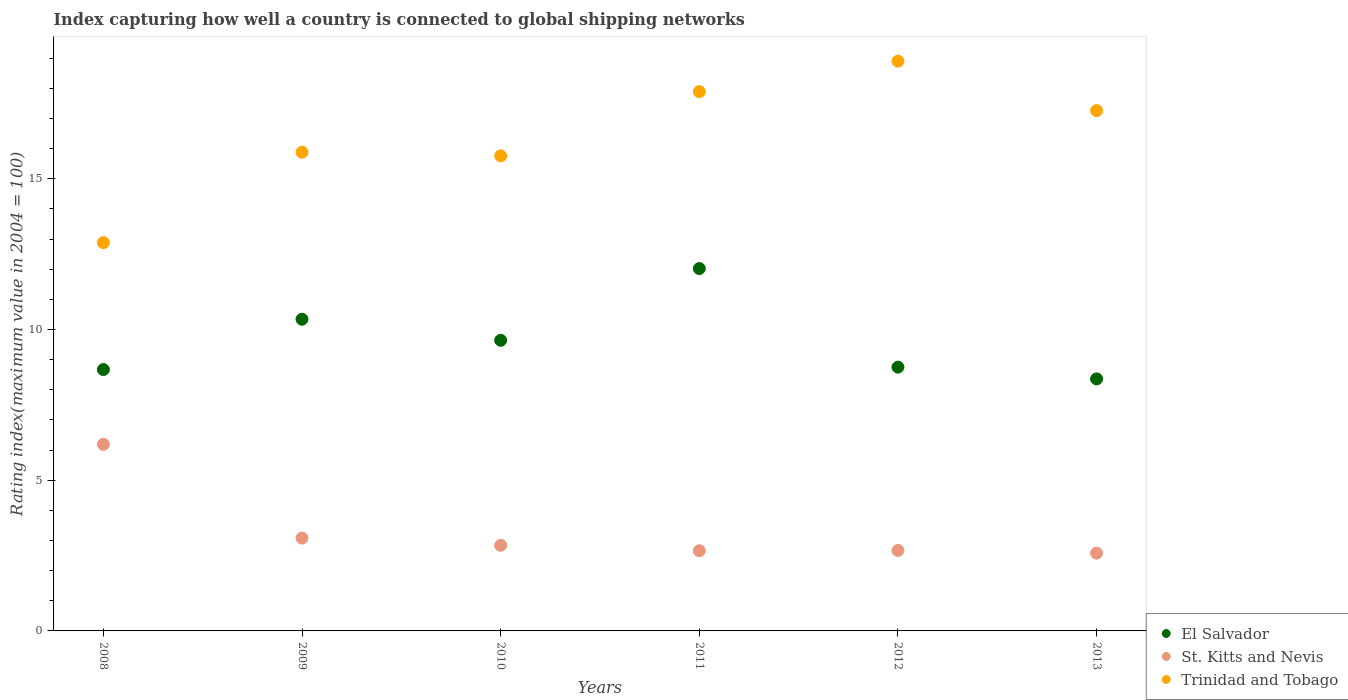How many different coloured dotlines are there?
Provide a succinct answer. 3. Is the number of dotlines equal to the number of legend labels?
Your answer should be very brief. Yes. What is the rating index in St. Kitts and Nevis in 2008?
Offer a very short reply. 6.19. Across all years, what is the maximum rating index in El Salvador?
Your response must be concise. 12.02. Across all years, what is the minimum rating index in St. Kitts and Nevis?
Give a very brief answer. 2.58. In which year was the rating index in El Salvador maximum?
Give a very brief answer. 2011. In which year was the rating index in El Salvador minimum?
Make the answer very short. 2013. What is the total rating index in St. Kitts and Nevis in the graph?
Keep it short and to the point. 20.02. What is the difference between the rating index in St. Kitts and Nevis in 2010 and that in 2012?
Your answer should be compact. 0.17. What is the difference between the rating index in St. Kitts and Nevis in 2010 and the rating index in Trinidad and Tobago in 2009?
Keep it short and to the point. -13.04. What is the average rating index in St. Kitts and Nevis per year?
Make the answer very short. 3.34. In the year 2011, what is the difference between the rating index in El Salvador and rating index in St. Kitts and Nevis?
Give a very brief answer. 9.36. In how many years, is the rating index in St. Kitts and Nevis greater than 2?
Offer a very short reply. 6. What is the ratio of the rating index in El Salvador in 2008 to that in 2013?
Offer a very short reply. 1.04. What is the difference between the highest and the second highest rating index in Trinidad and Tobago?
Offer a terse response. 1.01. What is the difference between the highest and the lowest rating index in El Salvador?
Provide a short and direct response. 3.66. In how many years, is the rating index in El Salvador greater than the average rating index in El Salvador taken over all years?
Ensure brevity in your answer.  3. Is the sum of the rating index in St. Kitts and Nevis in 2008 and 2011 greater than the maximum rating index in Trinidad and Tobago across all years?
Your answer should be compact. No. Does the rating index in El Salvador monotonically increase over the years?
Provide a short and direct response. No. Is the rating index in St. Kitts and Nevis strictly greater than the rating index in El Salvador over the years?
Your response must be concise. No. Is the rating index in Trinidad and Tobago strictly less than the rating index in El Salvador over the years?
Keep it short and to the point. No. How many years are there in the graph?
Make the answer very short. 6. Are the values on the major ticks of Y-axis written in scientific E-notation?
Your response must be concise. No. Where does the legend appear in the graph?
Your answer should be compact. Bottom right. How are the legend labels stacked?
Keep it short and to the point. Vertical. What is the title of the graph?
Your answer should be very brief. Index capturing how well a country is connected to global shipping networks. What is the label or title of the X-axis?
Provide a succinct answer. Years. What is the label or title of the Y-axis?
Your response must be concise. Rating index(maximum value in 2004 = 100). What is the Rating index(maximum value in 2004 = 100) of El Salvador in 2008?
Keep it short and to the point. 8.67. What is the Rating index(maximum value in 2004 = 100) in St. Kitts and Nevis in 2008?
Provide a succinct answer. 6.19. What is the Rating index(maximum value in 2004 = 100) of Trinidad and Tobago in 2008?
Your answer should be very brief. 12.88. What is the Rating index(maximum value in 2004 = 100) of El Salvador in 2009?
Your answer should be very brief. 10.34. What is the Rating index(maximum value in 2004 = 100) in St. Kitts and Nevis in 2009?
Your response must be concise. 3.08. What is the Rating index(maximum value in 2004 = 100) of Trinidad and Tobago in 2009?
Your answer should be very brief. 15.88. What is the Rating index(maximum value in 2004 = 100) in El Salvador in 2010?
Keep it short and to the point. 9.64. What is the Rating index(maximum value in 2004 = 100) in St. Kitts and Nevis in 2010?
Ensure brevity in your answer.  2.84. What is the Rating index(maximum value in 2004 = 100) in Trinidad and Tobago in 2010?
Make the answer very short. 15.76. What is the Rating index(maximum value in 2004 = 100) of El Salvador in 2011?
Provide a succinct answer. 12.02. What is the Rating index(maximum value in 2004 = 100) in St. Kitts and Nevis in 2011?
Provide a short and direct response. 2.66. What is the Rating index(maximum value in 2004 = 100) in Trinidad and Tobago in 2011?
Make the answer very short. 17.89. What is the Rating index(maximum value in 2004 = 100) of El Salvador in 2012?
Provide a short and direct response. 8.75. What is the Rating index(maximum value in 2004 = 100) of St. Kitts and Nevis in 2012?
Offer a terse response. 2.67. What is the Rating index(maximum value in 2004 = 100) in Trinidad and Tobago in 2012?
Offer a terse response. 18.9. What is the Rating index(maximum value in 2004 = 100) of El Salvador in 2013?
Give a very brief answer. 8.36. What is the Rating index(maximum value in 2004 = 100) in St. Kitts and Nevis in 2013?
Provide a succinct answer. 2.58. What is the Rating index(maximum value in 2004 = 100) in Trinidad and Tobago in 2013?
Your response must be concise. 17.26. Across all years, what is the maximum Rating index(maximum value in 2004 = 100) in El Salvador?
Give a very brief answer. 12.02. Across all years, what is the maximum Rating index(maximum value in 2004 = 100) in St. Kitts and Nevis?
Provide a short and direct response. 6.19. Across all years, what is the minimum Rating index(maximum value in 2004 = 100) in El Salvador?
Offer a terse response. 8.36. Across all years, what is the minimum Rating index(maximum value in 2004 = 100) in St. Kitts and Nevis?
Make the answer very short. 2.58. Across all years, what is the minimum Rating index(maximum value in 2004 = 100) in Trinidad and Tobago?
Your answer should be very brief. 12.88. What is the total Rating index(maximum value in 2004 = 100) of El Salvador in the graph?
Provide a succinct answer. 57.78. What is the total Rating index(maximum value in 2004 = 100) in St. Kitts and Nevis in the graph?
Make the answer very short. 20.02. What is the total Rating index(maximum value in 2004 = 100) in Trinidad and Tobago in the graph?
Make the answer very short. 98.57. What is the difference between the Rating index(maximum value in 2004 = 100) in El Salvador in 2008 and that in 2009?
Make the answer very short. -1.67. What is the difference between the Rating index(maximum value in 2004 = 100) in St. Kitts and Nevis in 2008 and that in 2009?
Ensure brevity in your answer.  3.11. What is the difference between the Rating index(maximum value in 2004 = 100) in El Salvador in 2008 and that in 2010?
Ensure brevity in your answer.  -0.97. What is the difference between the Rating index(maximum value in 2004 = 100) in St. Kitts and Nevis in 2008 and that in 2010?
Make the answer very short. 3.35. What is the difference between the Rating index(maximum value in 2004 = 100) of Trinidad and Tobago in 2008 and that in 2010?
Your answer should be compact. -2.88. What is the difference between the Rating index(maximum value in 2004 = 100) in El Salvador in 2008 and that in 2011?
Offer a very short reply. -3.35. What is the difference between the Rating index(maximum value in 2004 = 100) of St. Kitts and Nevis in 2008 and that in 2011?
Keep it short and to the point. 3.53. What is the difference between the Rating index(maximum value in 2004 = 100) of Trinidad and Tobago in 2008 and that in 2011?
Give a very brief answer. -5.01. What is the difference between the Rating index(maximum value in 2004 = 100) of El Salvador in 2008 and that in 2012?
Provide a succinct answer. -0.08. What is the difference between the Rating index(maximum value in 2004 = 100) of St. Kitts and Nevis in 2008 and that in 2012?
Your answer should be very brief. 3.52. What is the difference between the Rating index(maximum value in 2004 = 100) of Trinidad and Tobago in 2008 and that in 2012?
Your answer should be very brief. -6.02. What is the difference between the Rating index(maximum value in 2004 = 100) in El Salvador in 2008 and that in 2013?
Your answer should be very brief. 0.31. What is the difference between the Rating index(maximum value in 2004 = 100) in St. Kitts and Nevis in 2008 and that in 2013?
Keep it short and to the point. 3.61. What is the difference between the Rating index(maximum value in 2004 = 100) in Trinidad and Tobago in 2008 and that in 2013?
Your answer should be very brief. -4.38. What is the difference between the Rating index(maximum value in 2004 = 100) of El Salvador in 2009 and that in 2010?
Your response must be concise. 0.7. What is the difference between the Rating index(maximum value in 2004 = 100) in St. Kitts and Nevis in 2009 and that in 2010?
Offer a terse response. 0.24. What is the difference between the Rating index(maximum value in 2004 = 100) of Trinidad and Tobago in 2009 and that in 2010?
Keep it short and to the point. 0.12. What is the difference between the Rating index(maximum value in 2004 = 100) in El Salvador in 2009 and that in 2011?
Make the answer very short. -1.68. What is the difference between the Rating index(maximum value in 2004 = 100) of St. Kitts and Nevis in 2009 and that in 2011?
Provide a succinct answer. 0.42. What is the difference between the Rating index(maximum value in 2004 = 100) in Trinidad and Tobago in 2009 and that in 2011?
Ensure brevity in your answer.  -2.01. What is the difference between the Rating index(maximum value in 2004 = 100) in El Salvador in 2009 and that in 2012?
Provide a succinct answer. 1.59. What is the difference between the Rating index(maximum value in 2004 = 100) of St. Kitts and Nevis in 2009 and that in 2012?
Make the answer very short. 0.41. What is the difference between the Rating index(maximum value in 2004 = 100) in Trinidad and Tobago in 2009 and that in 2012?
Offer a very short reply. -3.02. What is the difference between the Rating index(maximum value in 2004 = 100) in El Salvador in 2009 and that in 2013?
Make the answer very short. 1.98. What is the difference between the Rating index(maximum value in 2004 = 100) in St. Kitts and Nevis in 2009 and that in 2013?
Keep it short and to the point. 0.5. What is the difference between the Rating index(maximum value in 2004 = 100) in Trinidad and Tobago in 2009 and that in 2013?
Give a very brief answer. -1.38. What is the difference between the Rating index(maximum value in 2004 = 100) in El Salvador in 2010 and that in 2011?
Offer a terse response. -2.38. What is the difference between the Rating index(maximum value in 2004 = 100) of St. Kitts and Nevis in 2010 and that in 2011?
Ensure brevity in your answer.  0.18. What is the difference between the Rating index(maximum value in 2004 = 100) of Trinidad and Tobago in 2010 and that in 2011?
Provide a succinct answer. -2.13. What is the difference between the Rating index(maximum value in 2004 = 100) in El Salvador in 2010 and that in 2012?
Give a very brief answer. 0.89. What is the difference between the Rating index(maximum value in 2004 = 100) in St. Kitts and Nevis in 2010 and that in 2012?
Give a very brief answer. 0.17. What is the difference between the Rating index(maximum value in 2004 = 100) of Trinidad and Tobago in 2010 and that in 2012?
Provide a short and direct response. -3.14. What is the difference between the Rating index(maximum value in 2004 = 100) in El Salvador in 2010 and that in 2013?
Offer a terse response. 1.28. What is the difference between the Rating index(maximum value in 2004 = 100) in St. Kitts and Nevis in 2010 and that in 2013?
Offer a very short reply. 0.26. What is the difference between the Rating index(maximum value in 2004 = 100) of El Salvador in 2011 and that in 2012?
Your answer should be very brief. 3.27. What is the difference between the Rating index(maximum value in 2004 = 100) in St. Kitts and Nevis in 2011 and that in 2012?
Give a very brief answer. -0.01. What is the difference between the Rating index(maximum value in 2004 = 100) of Trinidad and Tobago in 2011 and that in 2012?
Offer a terse response. -1.01. What is the difference between the Rating index(maximum value in 2004 = 100) of El Salvador in 2011 and that in 2013?
Give a very brief answer. 3.66. What is the difference between the Rating index(maximum value in 2004 = 100) of St. Kitts and Nevis in 2011 and that in 2013?
Provide a succinct answer. 0.08. What is the difference between the Rating index(maximum value in 2004 = 100) of Trinidad and Tobago in 2011 and that in 2013?
Provide a short and direct response. 0.63. What is the difference between the Rating index(maximum value in 2004 = 100) of El Salvador in 2012 and that in 2013?
Provide a short and direct response. 0.39. What is the difference between the Rating index(maximum value in 2004 = 100) in St. Kitts and Nevis in 2012 and that in 2013?
Offer a very short reply. 0.09. What is the difference between the Rating index(maximum value in 2004 = 100) in Trinidad and Tobago in 2012 and that in 2013?
Offer a terse response. 1.64. What is the difference between the Rating index(maximum value in 2004 = 100) in El Salvador in 2008 and the Rating index(maximum value in 2004 = 100) in St. Kitts and Nevis in 2009?
Provide a short and direct response. 5.59. What is the difference between the Rating index(maximum value in 2004 = 100) in El Salvador in 2008 and the Rating index(maximum value in 2004 = 100) in Trinidad and Tobago in 2009?
Ensure brevity in your answer.  -7.21. What is the difference between the Rating index(maximum value in 2004 = 100) of St. Kitts and Nevis in 2008 and the Rating index(maximum value in 2004 = 100) of Trinidad and Tobago in 2009?
Ensure brevity in your answer.  -9.69. What is the difference between the Rating index(maximum value in 2004 = 100) of El Salvador in 2008 and the Rating index(maximum value in 2004 = 100) of St. Kitts and Nevis in 2010?
Provide a short and direct response. 5.83. What is the difference between the Rating index(maximum value in 2004 = 100) in El Salvador in 2008 and the Rating index(maximum value in 2004 = 100) in Trinidad and Tobago in 2010?
Offer a terse response. -7.09. What is the difference between the Rating index(maximum value in 2004 = 100) in St. Kitts and Nevis in 2008 and the Rating index(maximum value in 2004 = 100) in Trinidad and Tobago in 2010?
Your response must be concise. -9.57. What is the difference between the Rating index(maximum value in 2004 = 100) in El Salvador in 2008 and the Rating index(maximum value in 2004 = 100) in St. Kitts and Nevis in 2011?
Keep it short and to the point. 6.01. What is the difference between the Rating index(maximum value in 2004 = 100) of El Salvador in 2008 and the Rating index(maximum value in 2004 = 100) of Trinidad and Tobago in 2011?
Your answer should be very brief. -9.22. What is the difference between the Rating index(maximum value in 2004 = 100) of St. Kitts and Nevis in 2008 and the Rating index(maximum value in 2004 = 100) of Trinidad and Tobago in 2011?
Ensure brevity in your answer.  -11.7. What is the difference between the Rating index(maximum value in 2004 = 100) in El Salvador in 2008 and the Rating index(maximum value in 2004 = 100) in St. Kitts and Nevis in 2012?
Ensure brevity in your answer.  6. What is the difference between the Rating index(maximum value in 2004 = 100) of El Salvador in 2008 and the Rating index(maximum value in 2004 = 100) of Trinidad and Tobago in 2012?
Make the answer very short. -10.23. What is the difference between the Rating index(maximum value in 2004 = 100) in St. Kitts and Nevis in 2008 and the Rating index(maximum value in 2004 = 100) in Trinidad and Tobago in 2012?
Your response must be concise. -12.71. What is the difference between the Rating index(maximum value in 2004 = 100) of El Salvador in 2008 and the Rating index(maximum value in 2004 = 100) of St. Kitts and Nevis in 2013?
Ensure brevity in your answer.  6.09. What is the difference between the Rating index(maximum value in 2004 = 100) in El Salvador in 2008 and the Rating index(maximum value in 2004 = 100) in Trinidad and Tobago in 2013?
Give a very brief answer. -8.59. What is the difference between the Rating index(maximum value in 2004 = 100) of St. Kitts and Nevis in 2008 and the Rating index(maximum value in 2004 = 100) of Trinidad and Tobago in 2013?
Your answer should be very brief. -11.07. What is the difference between the Rating index(maximum value in 2004 = 100) in El Salvador in 2009 and the Rating index(maximum value in 2004 = 100) in Trinidad and Tobago in 2010?
Your answer should be very brief. -5.42. What is the difference between the Rating index(maximum value in 2004 = 100) in St. Kitts and Nevis in 2009 and the Rating index(maximum value in 2004 = 100) in Trinidad and Tobago in 2010?
Offer a very short reply. -12.68. What is the difference between the Rating index(maximum value in 2004 = 100) in El Salvador in 2009 and the Rating index(maximum value in 2004 = 100) in St. Kitts and Nevis in 2011?
Ensure brevity in your answer.  7.68. What is the difference between the Rating index(maximum value in 2004 = 100) in El Salvador in 2009 and the Rating index(maximum value in 2004 = 100) in Trinidad and Tobago in 2011?
Make the answer very short. -7.55. What is the difference between the Rating index(maximum value in 2004 = 100) in St. Kitts and Nevis in 2009 and the Rating index(maximum value in 2004 = 100) in Trinidad and Tobago in 2011?
Your answer should be compact. -14.81. What is the difference between the Rating index(maximum value in 2004 = 100) in El Salvador in 2009 and the Rating index(maximum value in 2004 = 100) in St. Kitts and Nevis in 2012?
Offer a terse response. 7.67. What is the difference between the Rating index(maximum value in 2004 = 100) of El Salvador in 2009 and the Rating index(maximum value in 2004 = 100) of Trinidad and Tobago in 2012?
Provide a succinct answer. -8.56. What is the difference between the Rating index(maximum value in 2004 = 100) of St. Kitts and Nevis in 2009 and the Rating index(maximum value in 2004 = 100) of Trinidad and Tobago in 2012?
Your response must be concise. -15.82. What is the difference between the Rating index(maximum value in 2004 = 100) of El Salvador in 2009 and the Rating index(maximum value in 2004 = 100) of St. Kitts and Nevis in 2013?
Your response must be concise. 7.76. What is the difference between the Rating index(maximum value in 2004 = 100) of El Salvador in 2009 and the Rating index(maximum value in 2004 = 100) of Trinidad and Tobago in 2013?
Your answer should be very brief. -6.92. What is the difference between the Rating index(maximum value in 2004 = 100) of St. Kitts and Nevis in 2009 and the Rating index(maximum value in 2004 = 100) of Trinidad and Tobago in 2013?
Make the answer very short. -14.18. What is the difference between the Rating index(maximum value in 2004 = 100) in El Salvador in 2010 and the Rating index(maximum value in 2004 = 100) in St. Kitts and Nevis in 2011?
Ensure brevity in your answer.  6.98. What is the difference between the Rating index(maximum value in 2004 = 100) of El Salvador in 2010 and the Rating index(maximum value in 2004 = 100) of Trinidad and Tobago in 2011?
Offer a very short reply. -8.25. What is the difference between the Rating index(maximum value in 2004 = 100) in St. Kitts and Nevis in 2010 and the Rating index(maximum value in 2004 = 100) in Trinidad and Tobago in 2011?
Your answer should be compact. -15.05. What is the difference between the Rating index(maximum value in 2004 = 100) in El Salvador in 2010 and the Rating index(maximum value in 2004 = 100) in St. Kitts and Nevis in 2012?
Make the answer very short. 6.97. What is the difference between the Rating index(maximum value in 2004 = 100) of El Salvador in 2010 and the Rating index(maximum value in 2004 = 100) of Trinidad and Tobago in 2012?
Offer a very short reply. -9.26. What is the difference between the Rating index(maximum value in 2004 = 100) in St. Kitts and Nevis in 2010 and the Rating index(maximum value in 2004 = 100) in Trinidad and Tobago in 2012?
Offer a terse response. -16.06. What is the difference between the Rating index(maximum value in 2004 = 100) in El Salvador in 2010 and the Rating index(maximum value in 2004 = 100) in St. Kitts and Nevis in 2013?
Offer a terse response. 7.06. What is the difference between the Rating index(maximum value in 2004 = 100) of El Salvador in 2010 and the Rating index(maximum value in 2004 = 100) of Trinidad and Tobago in 2013?
Offer a terse response. -7.62. What is the difference between the Rating index(maximum value in 2004 = 100) of St. Kitts and Nevis in 2010 and the Rating index(maximum value in 2004 = 100) of Trinidad and Tobago in 2013?
Keep it short and to the point. -14.42. What is the difference between the Rating index(maximum value in 2004 = 100) in El Salvador in 2011 and the Rating index(maximum value in 2004 = 100) in St. Kitts and Nevis in 2012?
Your answer should be compact. 9.35. What is the difference between the Rating index(maximum value in 2004 = 100) in El Salvador in 2011 and the Rating index(maximum value in 2004 = 100) in Trinidad and Tobago in 2012?
Keep it short and to the point. -6.88. What is the difference between the Rating index(maximum value in 2004 = 100) in St. Kitts and Nevis in 2011 and the Rating index(maximum value in 2004 = 100) in Trinidad and Tobago in 2012?
Your answer should be compact. -16.24. What is the difference between the Rating index(maximum value in 2004 = 100) of El Salvador in 2011 and the Rating index(maximum value in 2004 = 100) of St. Kitts and Nevis in 2013?
Provide a short and direct response. 9.44. What is the difference between the Rating index(maximum value in 2004 = 100) of El Salvador in 2011 and the Rating index(maximum value in 2004 = 100) of Trinidad and Tobago in 2013?
Offer a very short reply. -5.24. What is the difference between the Rating index(maximum value in 2004 = 100) of St. Kitts and Nevis in 2011 and the Rating index(maximum value in 2004 = 100) of Trinidad and Tobago in 2013?
Your answer should be compact. -14.6. What is the difference between the Rating index(maximum value in 2004 = 100) of El Salvador in 2012 and the Rating index(maximum value in 2004 = 100) of St. Kitts and Nevis in 2013?
Provide a short and direct response. 6.17. What is the difference between the Rating index(maximum value in 2004 = 100) in El Salvador in 2012 and the Rating index(maximum value in 2004 = 100) in Trinidad and Tobago in 2013?
Ensure brevity in your answer.  -8.51. What is the difference between the Rating index(maximum value in 2004 = 100) in St. Kitts and Nevis in 2012 and the Rating index(maximum value in 2004 = 100) in Trinidad and Tobago in 2013?
Ensure brevity in your answer.  -14.59. What is the average Rating index(maximum value in 2004 = 100) of El Salvador per year?
Provide a succinct answer. 9.63. What is the average Rating index(maximum value in 2004 = 100) in St. Kitts and Nevis per year?
Give a very brief answer. 3.34. What is the average Rating index(maximum value in 2004 = 100) of Trinidad and Tobago per year?
Your response must be concise. 16.43. In the year 2008, what is the difference between the Rating index(maximum value in 2004 = 100) of El Salvador and Rating index(maximum value in 2004 = 100) of St. Kitts and Nevis?
Offer a terse response. 2.48. In the year 2008, what is the difference between the Rating index(maximum value in 2004 = 100) of El Salvador and Rating index(maximum value in 2004 = 100) of Trinidad and Tobago?
Provide a short and direct response. -4.21. In the year 2008, what is the difference between the Rating index(maximum value in 2004 = 100) in St. Kitts and Nevis and Rating index(maximum value in 2004 = 100) in Trinidad and Tobago?
Make the answer very short. -6.69. In the year 2009, what is the difference between the Rating index(maximum value in 2004 = 100) in El Salvador and Rating index(maximum value in 2004 = 100) in St. Kitts and Nevis?
Give a very brief answer. 7.26. In the year 2009, what is the difference between the Rating index(maximum value in 2004 = 100) of El Salvador and Rating index(maximum value in 2004 = 100) of Trinidad and Tobago?
Your answer should be very brief. -5.54. In the year 2009, what is the difference between the Rating index(maximum value in 2004 = 100) of St. Kitts and Nevis and Rating index(maximum value in 2004 = 100) of Trinidad and Tobago?
Give a very brief answer. -12.8. In the year 2010, what is the difference between the Rating index(maximum value in 2004 = 100) in El Salvador and Rating index(maximum value in 2004 = 100) in St. Kitts and Nevis?
Ensure brevity in your answer.  6.8. In the year 2010, what is the difference between the Rating index(maximum value in 2004 = 100) of El Salvador and Rating index(maximum value in 2004 = 100) of Trinidad and Tobago?
Your answer should be compact. -6.12. In the year 2010, what is the difference between the Rating index(maximum value in 2004 = 100) of St. Kitts and Nevis and Rating index(maximum value in 2004 = 100) of Trinidad and Tobago?
Keep it short and to the point. -12.92. In the year 2011, what is the difference between the Rating index(maximum value in 2004 = 100) in El Salvador and Rating index(maximum value in 2004 = 100) in St. Kitts and Nevis?
Give a very brief answer. 9.36. In the year 2011, what is the difference between the Rating index(maximum value in 2004 = 100) in El Salvador and Rating index(maximum value in 2004 = 100) in Trinidad and Tobago?
Keep it short and to the point. -5.87. In the year 2011, what is the difference between the Rating index(maximum value in 2004 = 100) in St. Kitts and Nevis and Rating index(maximum value in 2004 = 100) in Trinidad and Tobago?
Provide a short and direct response. -15.23. In the year 2012, what is the difference between the Rating index(maximum value in 2004 = 100) of El Salvador and Rating index(maximum value in 2004 = 100) of St. Kitts and Nevis?
Ensure brevity in your answer.  6.08. In the year 2012, what is the difference between the Rating index(maximum value in 2004 = 100) of El Salvador and Rating index(maximum value in 2004 = 100) of Trinidad and Tobago?
Offer a terse response. -10.15. In the year 2012, what is the difference between the Rating index(maximum value in 2004 = 100) of St. Kitts and Nevis and Rating index(maximum value in 2004 = 100) of Trinidad and Tobago?
Your answer should be compact. -16.23. In the year 2013, what is the difference between the Rating index(maximum value in 2004 = 100) in El Salvador and Rating index(maximum value in 2004 = 100) in St. Kitts and Nevis?
Give a very brief answer. 5.78. In the year 2013, what is the difference between the Rating index(maximum value in 2004 = 100) of St. Kitts and Nevis and Rating index(maximum value in 2004 = 100) of Trinidad and Tobago?
Offer a terse response. -14.68. What is the ratio of the Rating index(maximum value in 2004 = 100) of El Salvador in 2008 to that in 2009?
Provide a short and direct response. 0.84. What is the ratio of the Rating index(maximum value in 2004 = 100) in St. Kitts and Nevis in 2008 to that in 2009?
Provide a short and direct response. 2.01. What is the ratio of the Rating index(maximum value in 2004 = 100) in Trinidad and Tobago in 2008 to that in 2009?
Offer a terse response. 0.81. What is the ratio of the Rating index(maximum value in 2004 = 100) in El Salvador in 2008 to that in 2010?
Give a very brief answer. 0.9. What is the ratio of the Rating index(maximum value in 2004 = 100) of St. Kitts and Nevis in 2008 to that in 2010?
Provide a short and direct response. 2.18. What is the ratio of the Rating index(maximum value in 2004 = 100) of Trinidad and Tobago in 2008 to that in 2010?
Provide a succinct answer. 0.82. What is the ratio of the Rating index(maximum value in 2004 = 100) of El Salvador in 2008 to that in 2011?
Your response must be concise. 0.72. What is the ratio of the Rating index(maximum value in 2004 = 100) in St. Kitts and Nevis in 2008 to that in 2011?
Your response must be concise. 2.33. What is the ratio of the Rating index(maximum value in 2004 = 100) of Trinidad and Tobago in 2008 to that in 2011?
Your response must be concise. 0.72. What is the ratio of the Rating index(maximum value in 2004 = 100) of El Salvador in 2008 to that in 2012?
Give a very brief answer. 0.99. What is the ratio of the Rating index(maximum value in 2004 = 100) of St. Kitts and Nevis in 2008 to that in 2012?
Keep it short and to the point. 2.32. What is the ratio of the Rating index(maximum value in 2004 = 100) in Trinidad and Tobago in 2008 to that in 2012?
Provide a succinct answer. 0.68. What is the ratio of the Rating index(maximum value in 2004 = 100) in El Salvador in 2008 to that in 2013?
Ensure brevity in your answer.  1.04. What is the ratio of the Rating index(maximum value in 2004 = 100) of St. Kitts and Nevis in 2008 to that in 2013?
Your answer should be very brief. 2.4. What is the ratio of the Rating index(maximum value in 2004 = 100) in Trinidad and Tobago in 2008 to that in 2013?
Ensure brevity in your answer.  0.75. What is the ratio of the Rating index(maximum value in 2004 = 100) of El Salvador in 2009 to that in 2010?
Your answer should be very brief. 1.07. What is the ratio of the Rating index(maximum value in 2004 = 100) in St. Kitts and Nevis in 2009 to that in 2010?
Provide a succinct answer. 1.08. What is the ratio of the Rating index(maximum value in 2004 = 100) of Trinidad and Tobago in 2009 to that in 2010?
Provide a short and direct response. 1.01. What is the ratio of the Rating index(maximum value in 2004 = 100) of El Salvador in 2009 to that in 2011?
Make the answer very short. 0.86. What is the ratio of the Rating index(maximum value in 2004 = 100) in St. Kitts and Nevis in 2009 to that in 2011?
Provide a succinct answer. 1.16. What is the ratio of the Rating index(maximum value in 2004 = 100) of Trinidad and Tobago in 2009 to that in 2011?
Provide a succinct answer. 0.89. What is the ratio of the Rating index(maximum value in 2004 = 100) of El Salvador in 2009 to that in 2012?
Give a very brief answer. 1.18. What is the ratio of the Rating index(maximum value in 2004 = 100) in St. Kitts and Nevis in 2009 to that in 2012?
Make the answer very short. 1.15. What is the ratio of the Rating index(maximum value in 2004 = 100) of Trinidad and Tobago in 2009 to that in 2012?
Make the answer very short. 0.84. What is the ratio of the Rating index(maximum value in 2004 = 100) in El Salvador in 2009 to that in 2013?
Your answer should be compact. 1.24. What is the ratio of the Rating index(maximum value in 2004 = 100) of St. Kitts and Nevis in 2009 to that in 2013?
Your response must be concise. 1.19. What is the ratio of the Rating index(maximum value in 2004 = 100) of Trinidad and Tobago in 2009 to that in 2013?
Your answer should be compact. 0.92. What is the ratio of the Rating index(maximum value in 2004 = 100) of El Salvador in 2010 to that in 2011?
Keep it short and to the point. 0.8. What is the ratio of the Rating index(maximum value in 2004 = 100) of St. Kitts and Nevis in 2010 to that in 2011?
Ensure brevity in your answer.  1.07. What is the ratio of the Rating index(maximum value in 2004 = 100) of Trinidad and Tobago in 2010 to that in 2011?
Give a very brief answer. 0.88. What is the ratio of the Rating index(maximum value in 2004 = 100) of El Salvador in 2010 to that in 2012?
Make the answer very short. 1.1. What is the ratio of the Rating index(maximum value in 2004 = 100) in St. Kitts and Nevis in 2010 to that in 2012?
Offer a very short reply. 1.06. What is the ratio of the Rating index(maximum value in 2004 = 100) in Trinidad and Tobago in 2010 to that in 2012?
Offer a very short reply. 0.83. What is the ratio of the Rating index(maximum value in 2004 = 100) of El Salvador in 2010 to that in 2013?
Ensure brevity in your answer.  1.15. What is the ratio of the Rating index(maximum value in 2004 = 100) of St. Kitts and Nevis in 2010 to that in 2013?
Offer a terse response. 1.1. What is the ratio of the Rating index(maximum value in 2004 = 100) of Trinidad and Tobago in 2010 to that in 2013?
Keep it short and to the point. 0.91. What is the ratio of the Rating index(maximum value in 2004 = 100) of El Salvador in 2011 to that in 2012?
Provide a succinct answer. 1.37. What is the ratio of the Rating index(maximum value in 2004 = 100) in Trinidad and Tobago in 2011 to that in 2012?
Make the answer very short. 0.95. What is the ratio of the Rating index(maximum value in 2004 = 100) of El Salvador in 2011 to that in 2013?
Offer a terse response. 1.44. What is the ratio of the Rating index(maximum value in 2004 = 100) of St. Kitts and Nevis in 2011 to that in 2013?
Your answer should be very brief. 1.03. What is the ratio of the Rating index(maximum value in 2004 = 100) in Trinidad and Tobago in 2011 to that in 2013?
Keep it short and to the point. 1.04. What is the ratio of the Rating index(maximum value in 2004 = 100) in El Salvador in 2012 to that in 2013?
Provide a succinct answer. 1.05. What is the ratio of the Rating index(maximum value in 2004 = 100) of St. Kitts and Nevis in 2012 to that in 2013?
Offer a terse response. 1.03. What is the ratio of the Rating index(maximum value in 2004 = 100) of Trinidad and Tobago in 2012 to that in 2013?
Give a very brief answer. 1.09. What is the difference between the highest and the second highest Rating index(maximum value in 2004 = 100) of El Salvador?
Offer a terse response. 1.68. What is the difference between the highest and the second highest Rating index(maximum value in 2004 = 100) in St. Kitts and Nevis?
Your response must be concise. 3.11. What is the difference between the highest and the lowest Rating index(maximum value in 2004 = 100) in El Salvador?
Keep it short and to the point. 3.66. What is the difference between the highest and the lowest Rating index(maximum value in 2004 = 100) of St. Kitts and Nevis?
Ensure brevity in your answer.  3.61. What is the difference between the highest and the lowest Rating index(maximum value in 2004 = 100) of Trinidad and Tobago?
Ensure brevity in your answer.  6.02. 